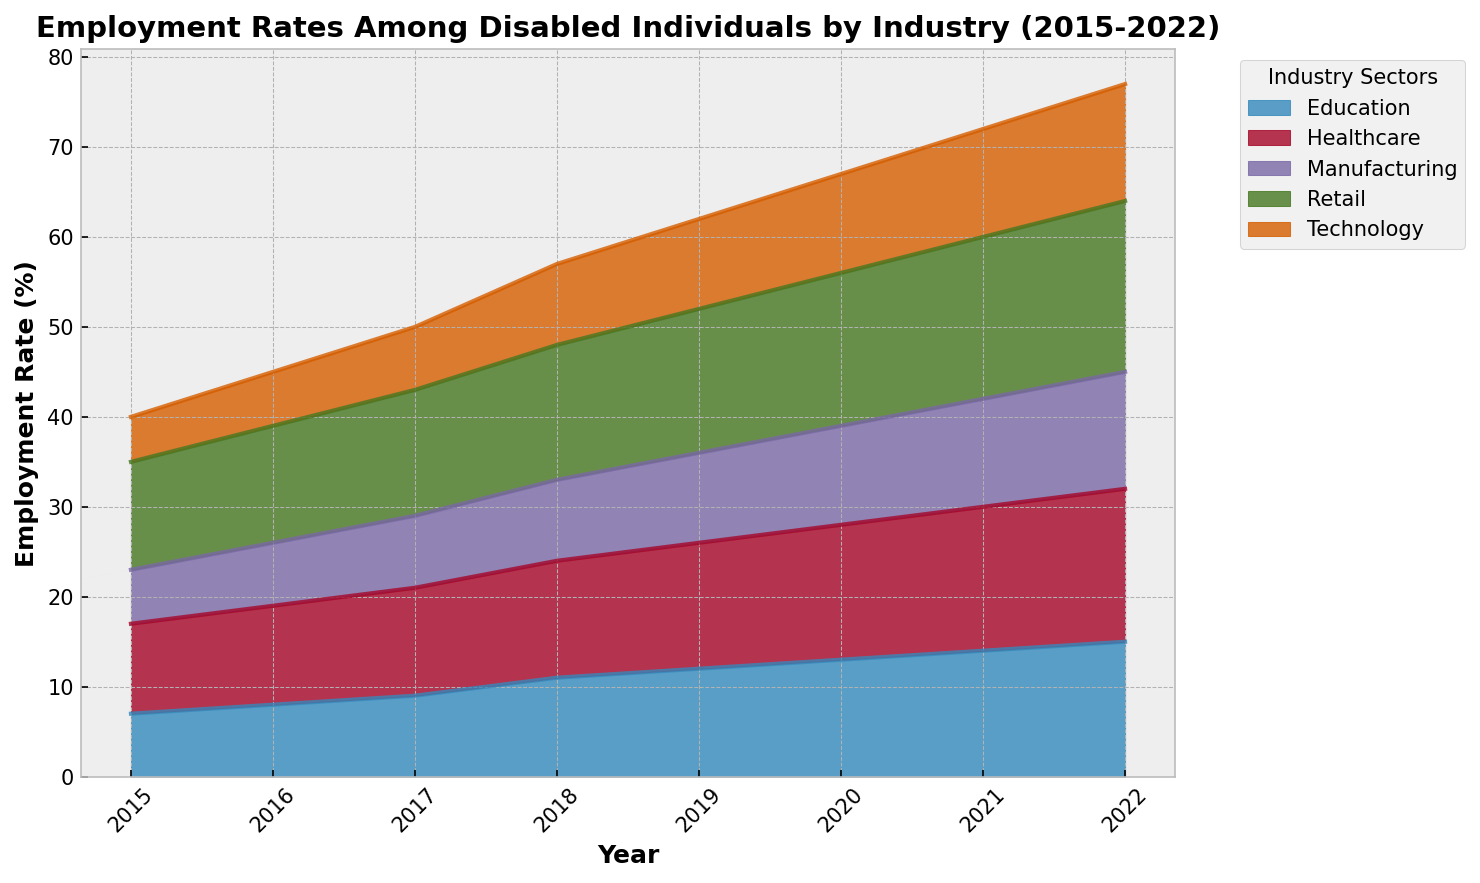what is the employment rate in the technology sector in 2020? Look for the data point in the technology sector for the year 2020 on the graph.
Answer: 11% Between 2015 and 2022, which year saw the highest employment rates in retail for disabled individuals? Compare the data points for the retail sector between 2015 and 2022 on the graph.
Answer: 2022 What is the average employment rate for the healthcare sector from 2015 to 2022? Sum the employment rates for the healthcare sector from 2015 to 2022 and divide by the number of years: (10 + 11 + 12 + 13 + 14 + 15 + 16 + 17) / 8.
Answer: 13% How did the employment rates in the manufacturing sector change from 2015 to 2022? Observe the changes in the manufacturing sector's area in the graph from 2015 to 2022. It consistently increases each year.
Answer: Increased Comparing 2019 and 2020, which industry saw the greatest increase in employment rate? Check the differences for each industry from 2019 to 2020: Technology (10 to 11), Healthcare (14 to 15), Education (12 to 13), Retail (16 to 17), Manufacturing (10 to 11). All increase by 1% so none stands out.
Answer: None What is the total employment rate for all sectors combined in 2017? Add the employment rates of all sectors in 2017: 7 (Tech) + 12 (Healthcare) + 9 (Education) + 14 (Retail) + 8 (Manufacturing).
Answer: 50% Which sector exhibited the greatest consistent growth trend from 2015 to 2022? Evaluate the slope and consistency of increases visually for each sector from 2015 to 2022. The technology sector grows steadily from 5% to 13%.
Answer: Technology By how much did the employment rate in the technology sector increase from 2016 to 2018? Subtract the employment rate of the technology sector in 2016 (6%) from that in 2018 (9%).
Answer: 3% In which year did the education sector first surpass the employment rate of the manufacturing sector? Compare the education and manufacturing sectors on the chart year by year. In 2018, Education reaches 11%, while Manufacturing is at 9%.
Answer: 2018 